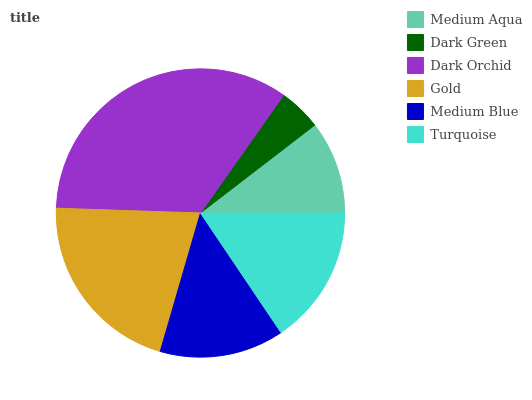Is Dark Green the minimum?
Answer yes or no. Yes. Is Dark Orchid the maximum?
Answer yes or no. Yes. Is Dark Orchid the minimum?
Answer yes or no. No. Is Dark Green the maximum?
Answer yes or no. No. Is Dark Orchid greater than Dark Green?
Answer yes or no. Yes. Is Dark Green less than Dark Orchid?
Answer yes or no. Yes. Is Dark Green greater than Dark Orchid?
Answer yes or no. No. Is Dark Orchid less than Dark Green?
Answer yes or no. No. Is Turquoise the high median?
Answer yes or no. Yes. Is Medium Blue the low median?
Answer yes or no. Yes. Is Dark Green the high median?
Answer yes or no. No. Is Turquoise the low median?
Answer yes or no. No. 